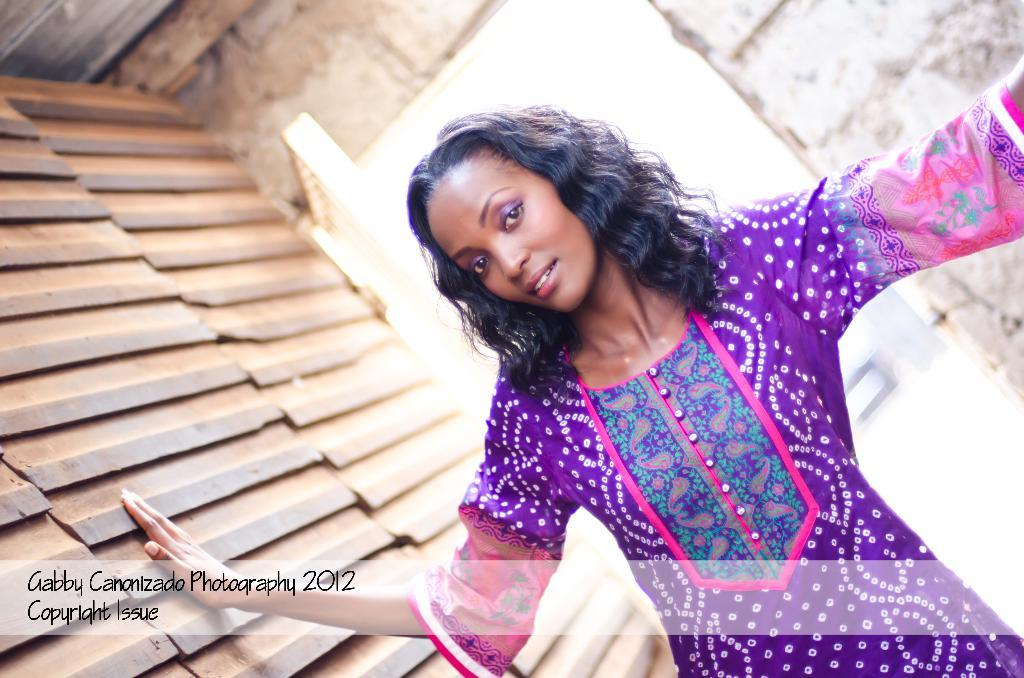Who is present in the image? There is a woman in the image. What can be seen in the background of the image? There is a wall in the background of the image. Where is the text located in the image? The text is visible on the bottom left of the image. What type of seed is the bee carrying in the image? There is no bee or seed present in the image. What kind of bear can be seen in the image? There is no bear present in the image. 